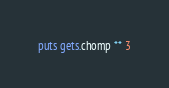Convert code to text. <code><loc_0><loc_0><loc_500><loc_500><_Ruby_>puts gets.chomp ** 3</code> 